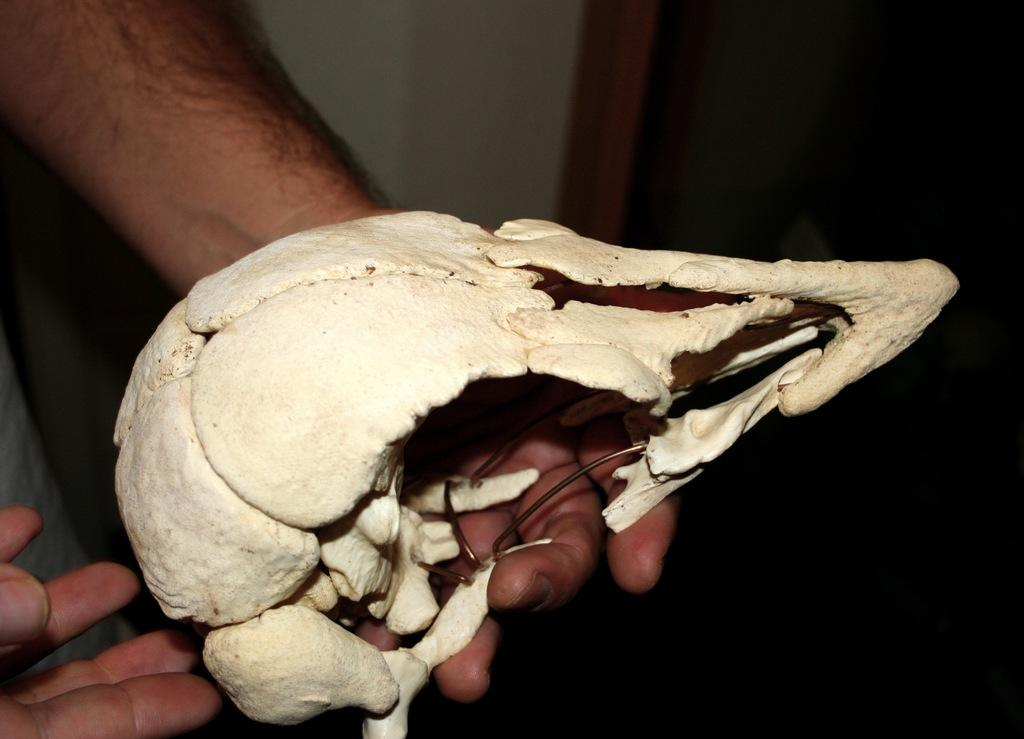What is the main subject of the image? The main subject of the image is a bone structure. What color is the bone structure? The bone structure is cream colored. Where is the bone structure located? The bone structure is in a human hand. What colors can be seen in the background of the image? The background of the image is white, brown, and black colored. What type of zebra can be seen in the background of the image? There is no zebra present in the image; the background is white, brown, and black colored. 